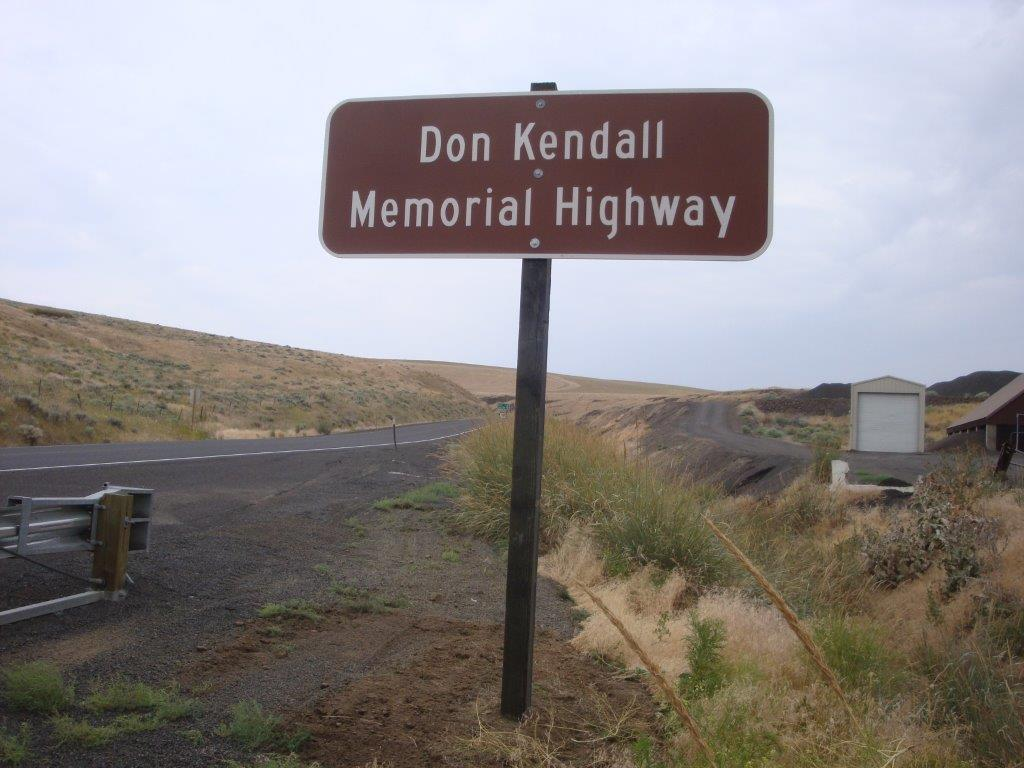What is the main object in the middle of the image? There is a board in the middle of the image. What can be seen on the left side of the image? There is a road on the left side of the image. What is visible at the top of the image? The sky is visible at the top of the image. How would you describe the sky in the image? The sky appears to be cloudy. What type of blade is being used to cut the elbow in the image? There is no blade or elbow present in the image; it only features a board, a road, and a cloudy sky. 